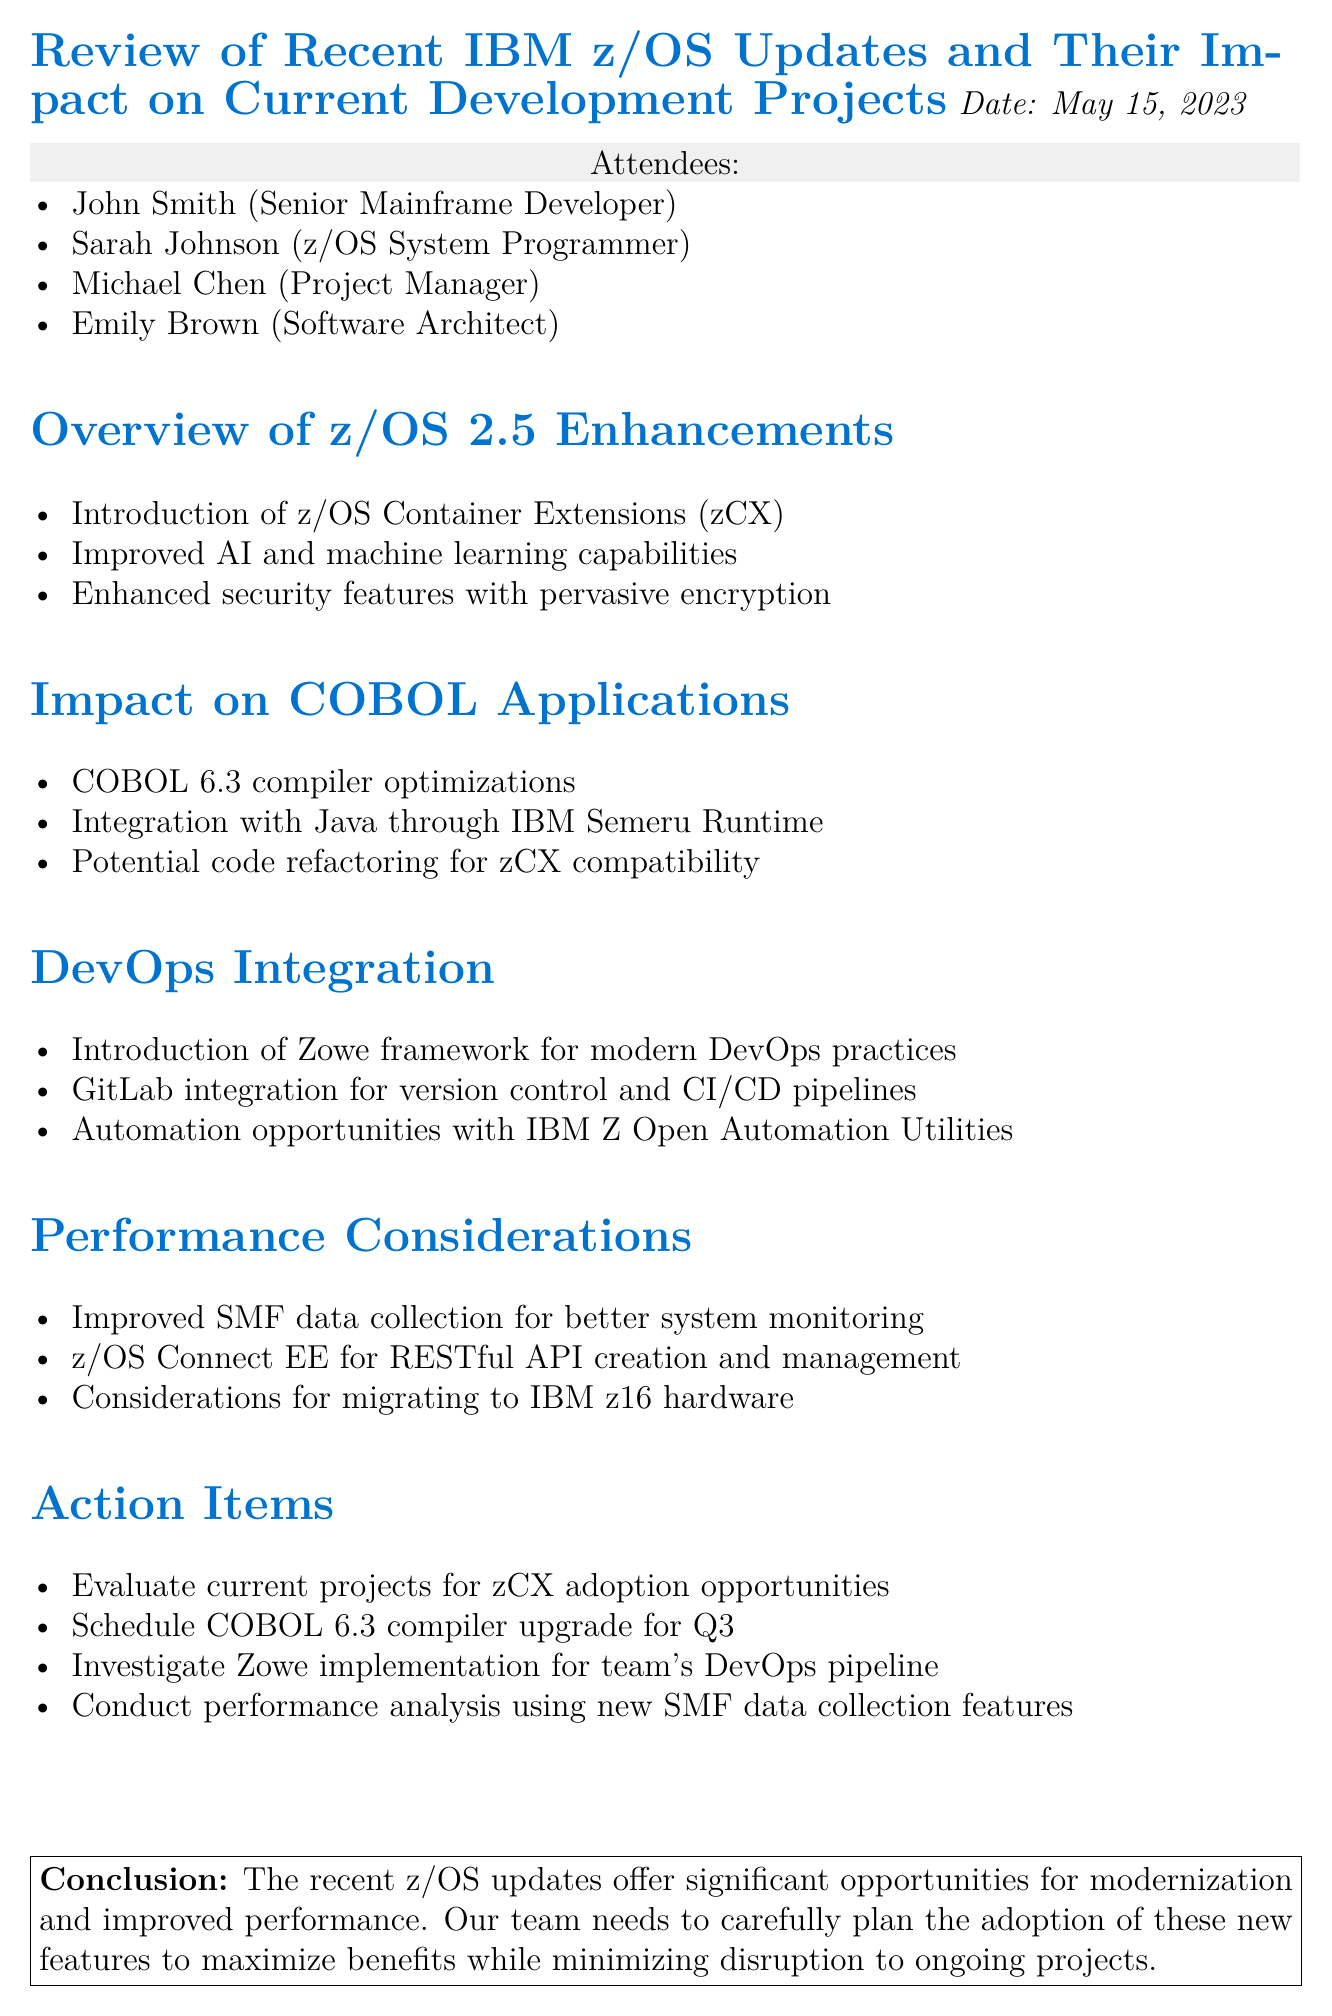What is the date of the meeting? The date of the meeting is explicitly stated in the document.
Answer: May 15, 2023 Who is the Senior Mainframe Developer? The document lists attendees and their titles, providing the name of the Senior Mainframe Developer.
Answer: John Smith What are the new capabilities introduced in z/OS 2.5? The document outlines key points regarding z/OS 2.5 enhancements, including several new capabilities.
Answer: z/OS Container Extensions What is one potential issue with COBOL applications? The document mentions a specific concern regarding COBOL applications that may need addressing.
Answer: Code refactoring for zCX compatibility What is the Zowe framework related to? The document discusses the Zowe framework in the context of a specific modern practice in development.
Answer: DevOps practices How many action items are listed? The document clearly enumerates the action items, allowing us to count them directly.
Answer: Four What is one consideration for migrating to new hardware? The document provides considerations related to hardware migration specifically mentioning new technology.
Answer: IBM z16 hardware What is the conclusion regarding z/OS updates? The conclusion summarizes the overall impact of the updates mentioned in the meeting minutes.
Answer: Significant opportunities for modernization 